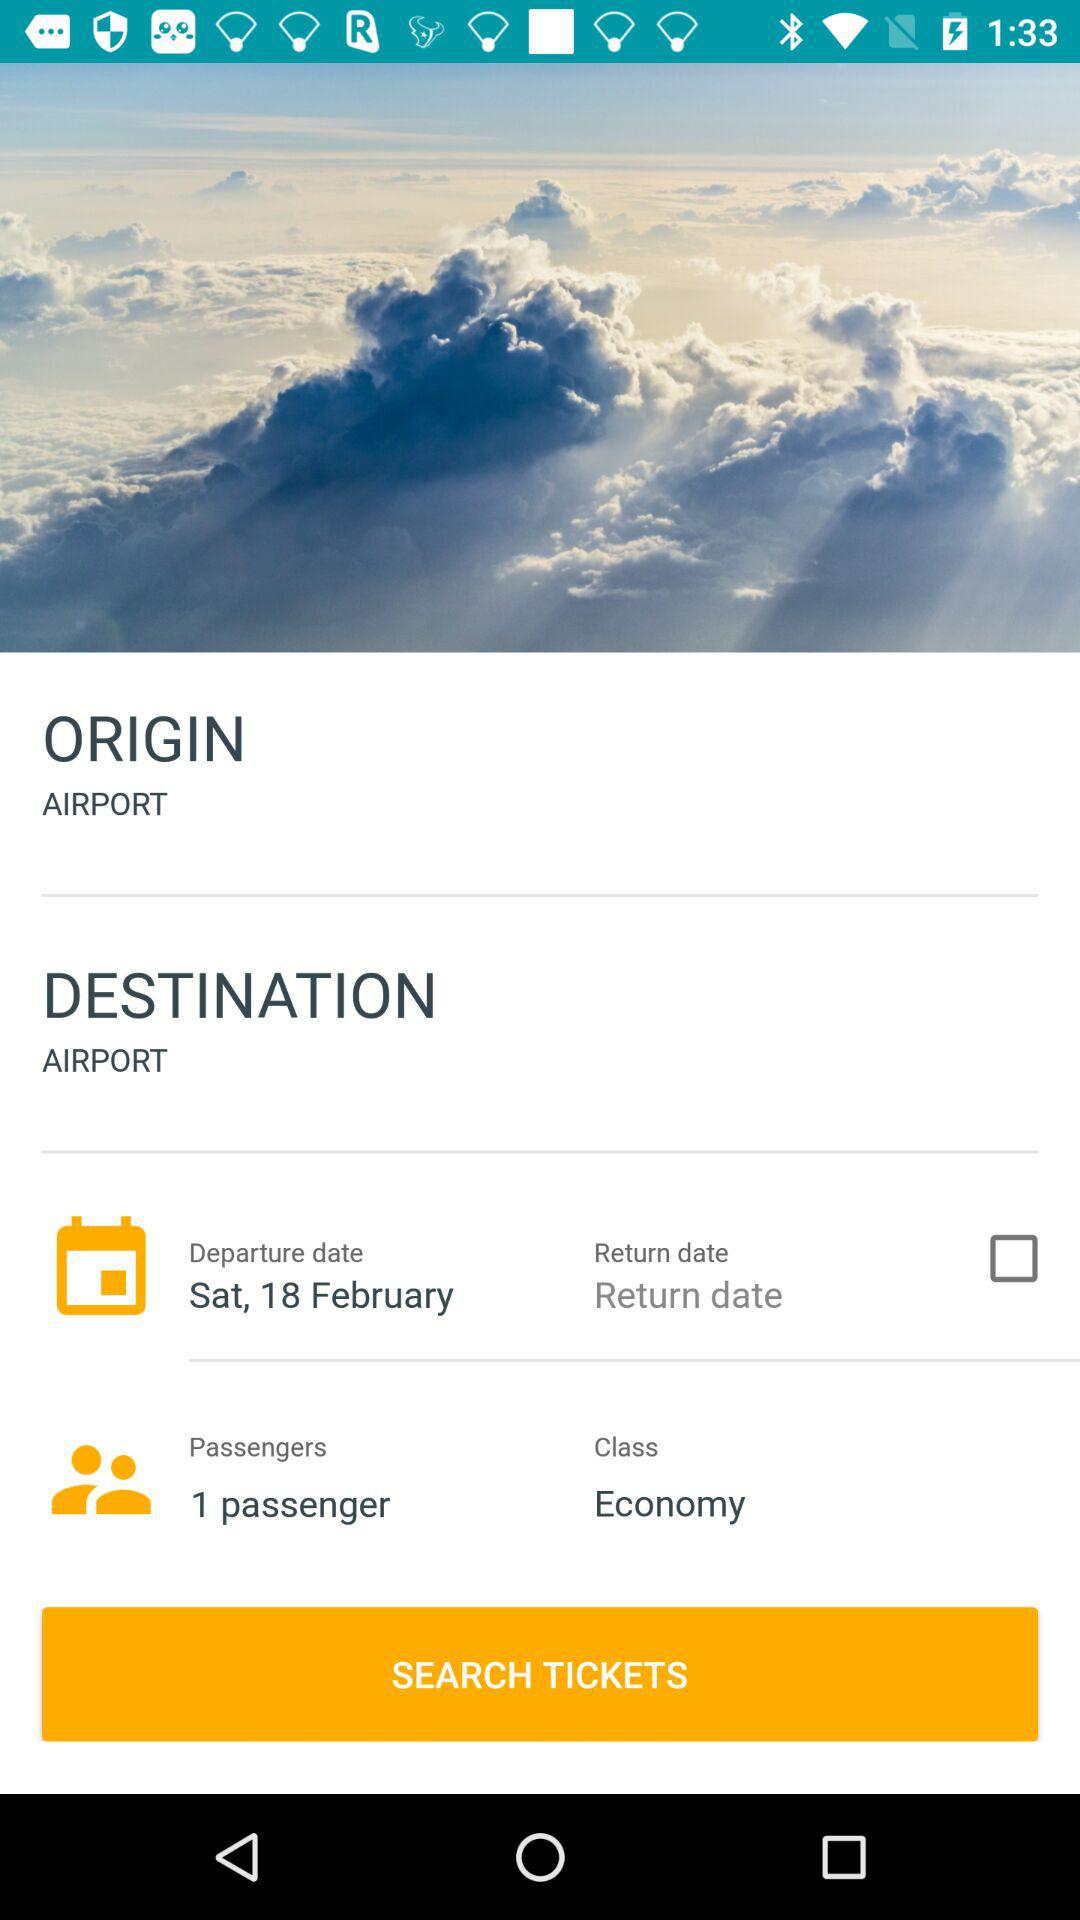What is the status of the return date? The status of the return date is off. 